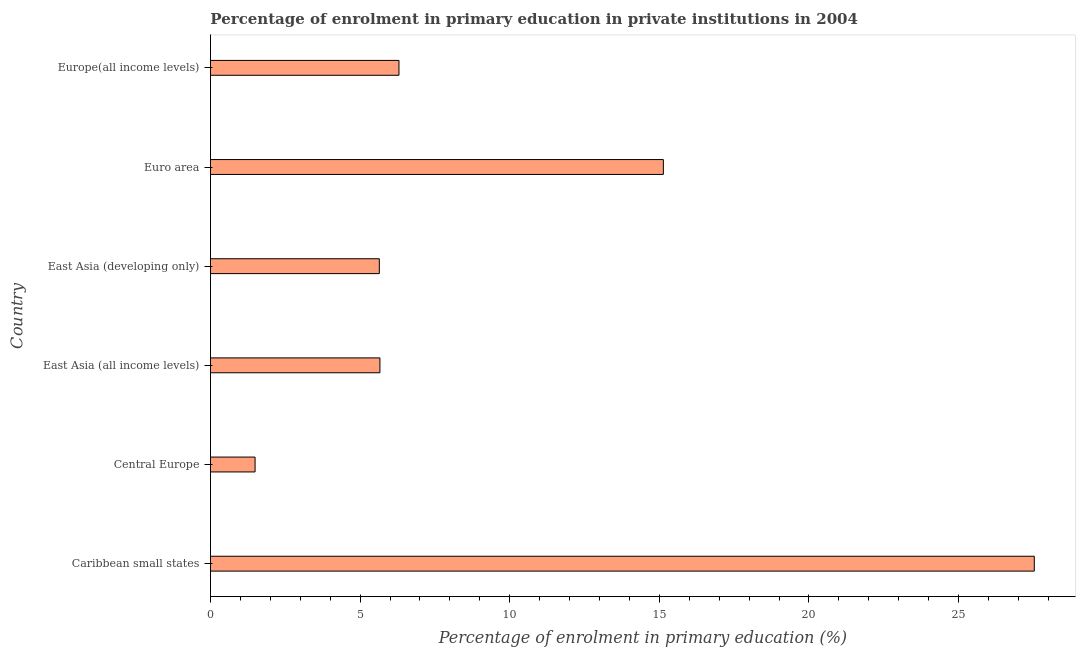Does the graph contain grids?
Your answer should be very brief. No. What is the title of the graph?
Give a very brief answer. Percentage of enrolment in primary education in private institutions in 2004. What is the label or title of the X-axis?
Give a very brief answer. Percentage of enrolment in primary education (%). What is the label or title of the Y-axis?
Keep it short and to the point. Country. What is the enrolment percentage in primary education in East Asia (all income levels)?
Offer a very short reply. 5.66. Across all countries, what is the maximum enrolment percentage in primary education?
Make the answer very short. 27.53. Across all countries, what is the minimum enrolment percentage in primary education?
Your answer should be compact. 1.49. In which country was the enrolment percentage in primary education maximum?
Make the answer very short. Caribbean small states. In which country was the enrolment percentage in primary education minimum?
Make the answer very short. Central Europe. What is the sum of the enrolment percentage in primary education?
Provide a succinct answer. 61.76. What is the difference between the enrolment percentage in primary education in East Asia (developing only) and Euro area?
Ensure brevity in your answer.  -9.49. What is the average enrolment percentage in primary education per country?
Offer a very short reply. 10.29. What is the median enrolment percentage in primary education?
Your answer should be compact. 5.98. In how many countries, is the enrolment percentage in primary education greater than 13 %?
Your answer should be very brief. 2. What is the ratio of the enrolment percentage in primary education in East Asia (developing only) to that in Euro area?
Your answer should be compact. 0.37. Is the enrolment percentage in primary education in Central Europe less than that in Europe(all income levels)?
Make the answer very short. Yes. What is the difference between the highest and the second highest enrolment percentage in primary education?
Keep it short and to the point. 12.4. Is the sum of the enrolment percentage in primary education in Central Europe and Europe(all income levels) greater than the maximum enrolment percentage in primary education across all countries?
Your answer should be compact. No. What is the difference between the highest and the lowest enrolment percentage in primary education?
Provide a succinct answer. 26.04. How many bars are there?
Your response must be concise. 6. Are all the bars in the graph horizontal?
Ensure brevity in your answer.  Yes. What is the difference between two consecutive major ticks on the X-axis?
Make the answer very short. 5. What is the Percentage of enrolment in primary education (%) of Caribbean small states?
Provide a succinct answer. 27.53. What is the Percentage of enrolment in primary education (%) of Central Europe?
Keep it short and to the point. 1.49. What is the Percentage of enrolment in primary education (%) of East Asia (all income levels)?
Provide a succinct answer. 5.66. What is the Percentage of enrolment in primary education (%) in East Asia (developing only)?
Offer a very short reply. 5.64. What is the Percentage of enrolment in primary education (%) of Euro area?
Ensure brevity in your answer.  15.13. What is the Percentage of enrolment in primary education (%) of Europe(all income levels)?
Give a very brief answer. 6.3. What is the difference between the Percentage of enrolment in primary education (%) in Caribbean small states and Central Europe?
Offer a terse response. 26.04. What is the difference between the Percentage of enrolment in primary education (%) in Caribbean small states and East Asia (all income levels)?
Ensure brevity in your answer.  21.87. What is the difference between the Percentage of enrolment in primary education (%) in Caribbean small states and East Asia (developing only)?
Provide a short and direct response. 21.89. What is the difference between the Percentage of enrolment in primary education (%) in Caribbean small states and Euro area?
Keep it short and to the point. 12.4. What is the difference between the Percentage of enrolment in primary education (%) in Caribbean small states and Europe(all income levels)?
Offer a very short reply. 21.23. What is the difference between the Percentage of enrolment in primary education (%) in Central Europe and East Asia (all income levels)?
Give a very brief answer. -4.17. What is the difference between the Percentage of enrolment in primary education (%) in Central Europe and East Asia (developing only)?
Give a very brief answer. -4.15. What is the difference between the Percentage of enrolment in primary education (%) in Central Europe and Euro area?
Your response must be concise. -13.64. What is the difference between the Percentage of enrolment in primary education (%) in Central Europe and Europe(all income levels)?
Your answer should be very brief. -4.81. What is the difference between the Percentage of enrolment in primary education (%) in East Asia (all income levels) and East Asia (developing only)?
Ensure brevity in your answer.  0.02. What is the difference between the Percentage of enrolment in primary education (%) in East Asia (all income levels) and Euro area?
Keep it short and to the point. -9.47. What is the difference between the Percentage of enrolment in primary education (%) in East Asia (all income levels) and Europe(all income levels)?
Give a very brief answer. -0.64. What is the difference between the Percentage of enrolment in primary education (%) in East Asia (developing only) and Euro area?
Ensure brevity in your answer.  -9.49. What is the difference between the Percentage of enrolment in primary education (%) in East Asia (developing only) and Europe(all income levels)?
Ensure brevity in your answer.  -0.66. What is the difference between the Percentage of enrolment in primary education (%) in Euro area and Europe(all income levels)?
Your response must be concise. 8.84. What is the ratio of the Percentage of enrolment in primary education (%) in Caribbean small states to that in Central Europe?
Your answer should be compact. 18.47. What is the ratio of the Percentage of enrolment in primary education (%) in Caribbean small states to that in East Asia (all income levels)?
Ensure brevity in your answer.  4.86. What is the ratio of the Percentage of enrolment in primary education (%) in Caribbean small states to that in East Asia (developing only)?
Make the answer very short. 4.88. What is the ratio of the Percentage of enrolment in primary education (%) in Caribbean small states to that in Euro area?
Your response must be concise. 1.82. What is the ratio of the Percentage of enrolment in primary education (%) in Caribbean small states to that in Europe(all income levels)?
Your answer should be compact. 4.37. What is the ratio of the Percentage of enrolment in primary education (%) in Central Europe to that in East Asia (all income levels)?
Give a very brief answer. 0.26. What is the ratio of the Percentage of enrolment in primary education (%) in Central Europe to that in East Asia (developing only)?
Make the answer very short. 0.26. What is the ratio of the Percentage of enrolment in primary education (%) in Central Europe to that in Euro area?
Provide a succinct answer. 0.1. What is the ratio of the Percentage of enrolment in primary education (%) in Central Europe to that in Europe(all income levels)?
Offer a terse response. 0.24. What is the ratio of the Percentage of enrolment in primary education (%) in East Asia (all income levels) to that in East Asia (developing only)?
Offer a very short reply. 1. What is the ratio of the Percentage of enrolment in primary education (%) in East Asia (all income levels) to that in Euro area?
Keep it short and to the point. 0.37. What is the ratio of the Percentage of enrolment in primary education (%) in East Asia (all income levels) to that in Europe(all income levels)?
Keep it short and to the point. 0.9. What is the ratio of the Percentage of enrolment in primary education (%) in East Asia (developing only) to that in Euro area?
Ensure brevity in your answer.  0.37. What is the ratio of the Percentage of enrolment in primary education (%) in East Asia (developing only) to that in Europe(all income levels)?
Keep it short and to the point. 0.9. What is the ratio of the Percentage of enrolment in primary education (%) in Euro area to that in Europe(all income levels)?
Offer a very short reply. 2.4. 